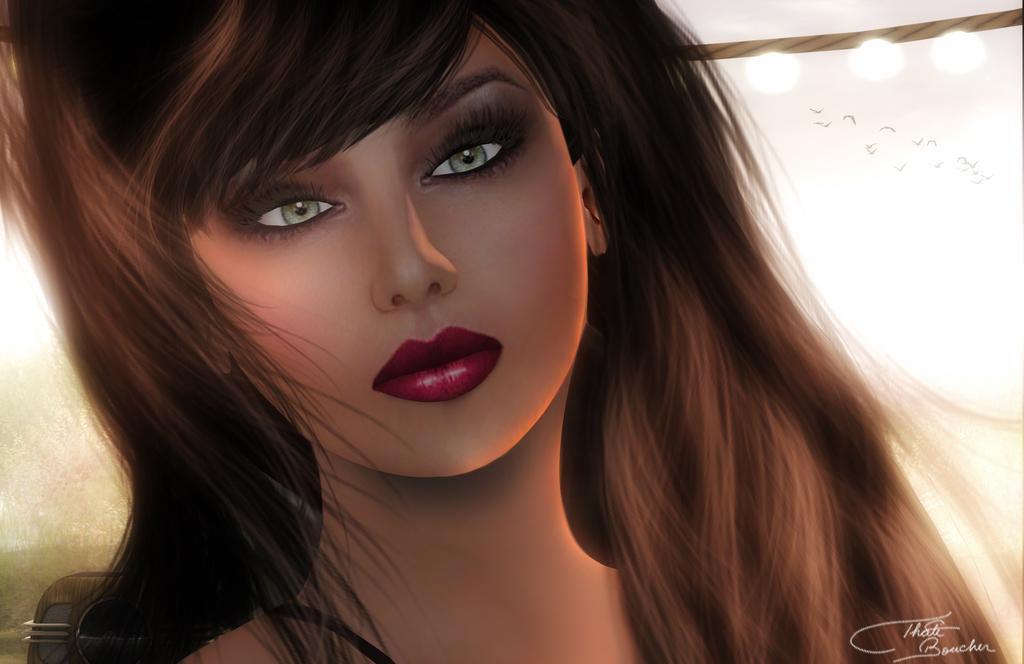How would you summarize this image in a sentence or two? This is an animated image of a person, there are some lights and birds, at the bottom of the image we can see the text. 